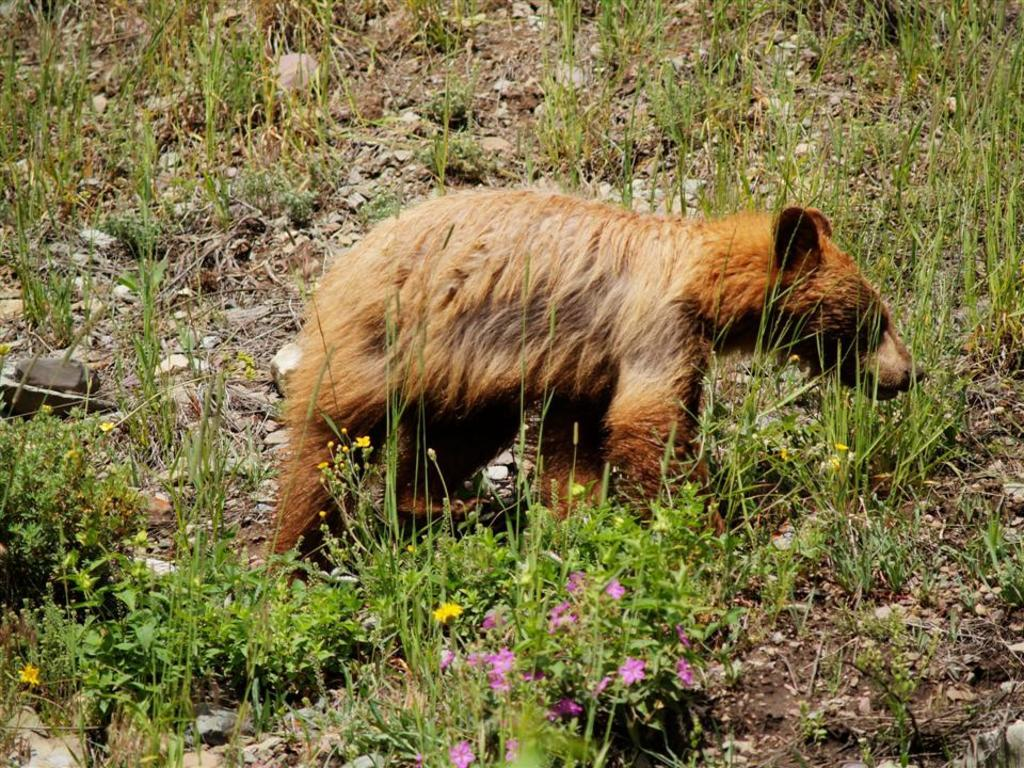What is the main subject in the center of the image? There is a bear in the center of the image. What can be seen in front of the bear? There are plants and flowers in front of the image. What type of surface is visible at the bottom of the image? There is grass on the surface at the bottom of the image. How many apples are hanging from the branches of the trees in the image? There are no trees or apples present in the image; it features a bear and plants/flowers. 